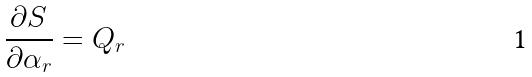<formula> <loc_0><loc_0><loc_500><loc_500>\frac { \partial S } { \partial \alpha _ { r } } = Q _ { r }</formula> 